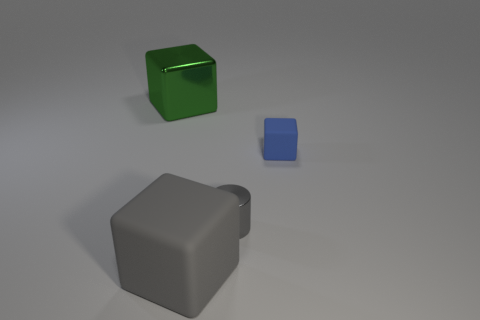Add 3 gray shiny things. How many objects exist? 7 Subtract all large gray cubes. How many cubes are left? 2 Subtract all green cubes. How many cubes are left? 2 Subtract all blue balls. How many gray blocks are left? 1 Subtract all big green metallic cubes. Subtract all big objects. How many objects are left? 1 Add 2 big green cubes. How many big green cubes are left? 3 Add 1 green metal balls. How many green metal balls exist? 1 Subtract 0 cyan balls. How many objects are left? 4 Subtract all cubes. How many objects are left? 1 Subtract 1 cubes. How many cubes are left? 2 